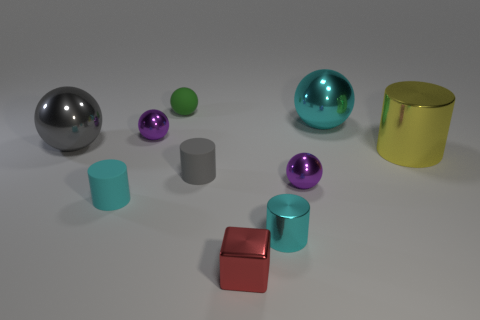Subtract all gray balls. How many balls are left? 4 Subtract all cyan spheres. How many spheres are left? 4 Subtract all red spheres. Subtract all blue cubes. How many spheres are left? 5 Subtract all cylinders. How many objects are left? 6 Subtract 1 green spheres. How many objects are left? 9 Subtract all gray rubber objects. Subtract all small gray matte objects. How many objects are left? 8 Add 2 yellow objects. How many yellow objects are left? 3 Add 6 metal cylinders. How many metal cylinders exist? 8 